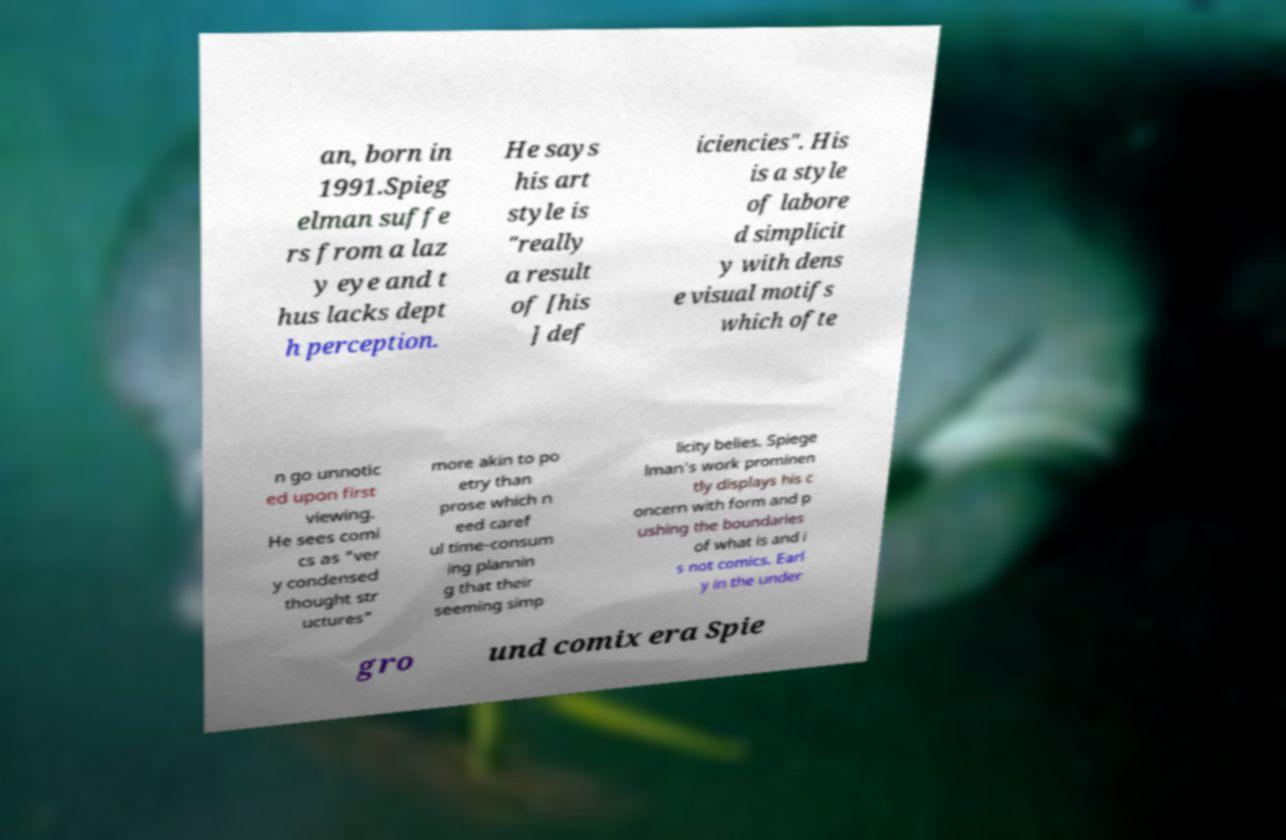Can you accurately transcribe the text from the provided image for me? an, born in 1991.Spieg elman suffe rs from a laz y eye and t hus lacks dept h perception. He says his art style is "really a result of [his ] def iciencies". His is a style of labore d simplicit y with dens e visual motifs which ofte n go unnotic ed upon first viewing. He sees comi cs as "ver y condensed thought str uctures" more akin to po etry than prose which n eed caref ul time-consum ing plannin g that their seeming simp licity belies. Spiege lman's work prominen tly displays his c oncern with form and p ushing the boundaries of what is and i s not comics. Earl y in the under gro und comix era Spie 